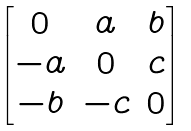Convert formula to latex. <formula><loc_0><loc_0><loc_500><loc_500>\begin{bmatrix} 0 & a & b \\ - a & 0 & c \\ - b & - c & 0 \end{bmatrix}</formula> 